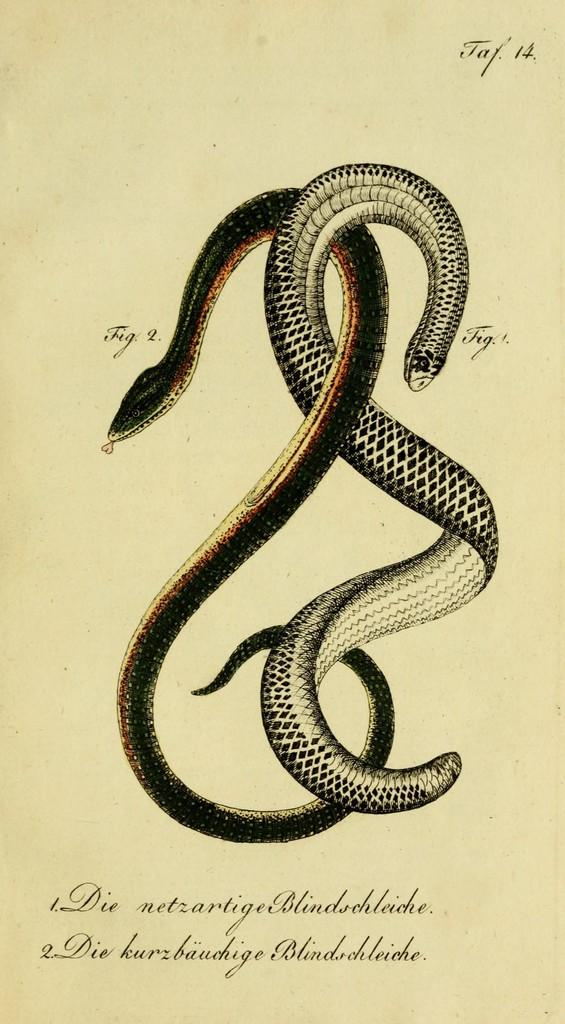What is depicted in the image? There are drawings of two snakes in the image. Is there any text present in the image? Yes, there is text written on the bottom right of the image. How many dinosaurs can be seen in the image? There are no dinosaurs present in the image; it features drawings of two snakes. What type of trick is being performed by the snakes in the image? There is no trick being performed by the snakes in the image; they are simply depicted as drawings. 